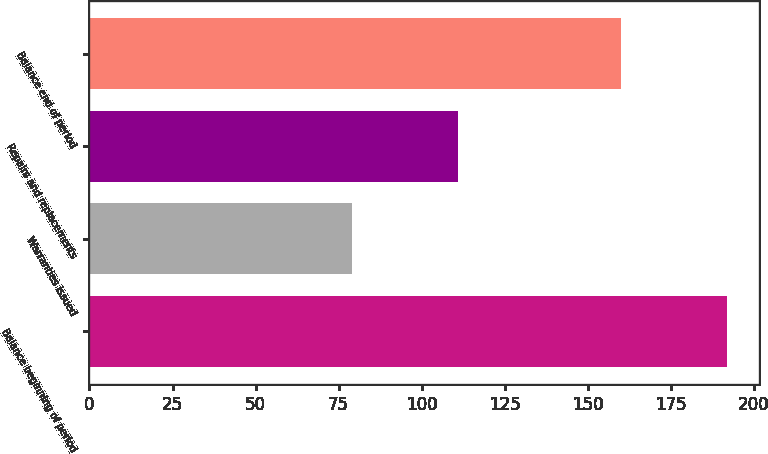Convert chart to OTSL. <chart><loc_0><loc_0><loc_500><loc_500><bar_chart><fcel>Balance beginning of period<fcel>Warranties issued<fcel>Repairs and replacements<fcel>Balance end of period<nl><fcel>192<fcel>79<fcel>111<fcel>160<nl></chart> 